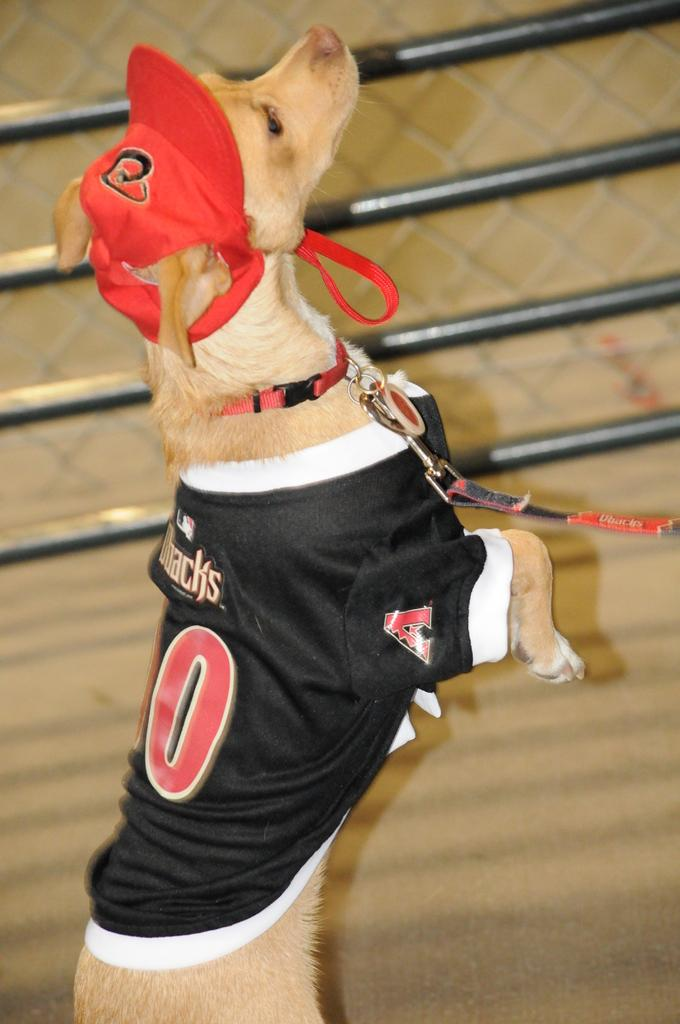<image>
Provide a brief description of the given image. a dog with an arizona diamondbacks jersey on 